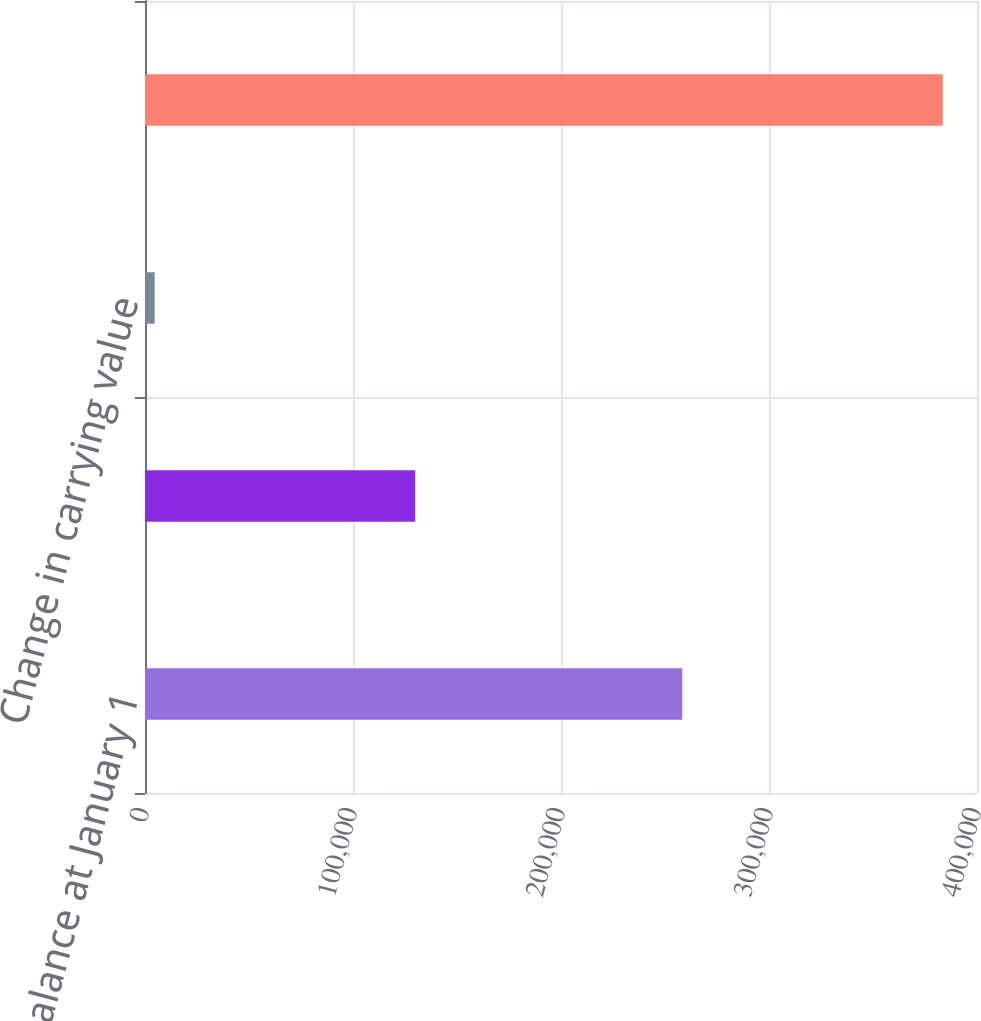Convert chart to OTSL. <chart><loc_0><loc_0><loc_500><loc_500><bar_chart><fcel>Balance at January 1<fcel>Change in market value<fcel>Change in carrying value<fcel>Balance at December 31<nl><fcel>258280<fcel>129918<fcel>4658<fcel>383540<nl></chart> 